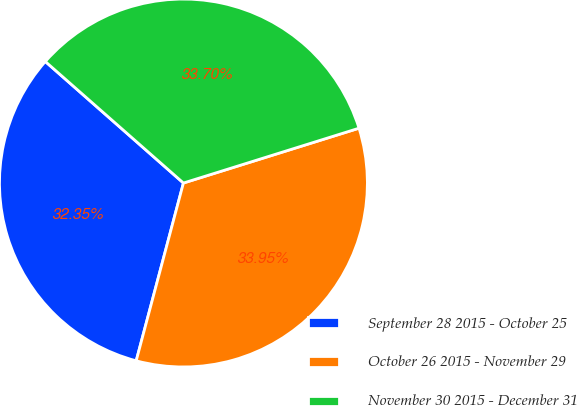Convert chart to OTSL. <chart><loc_0><loc_0><loc_500><loc_500><pie_chart><fcel>September 28 2015 - October 25<fcel>October 26 2015 - November 29<fcel>November 30 2015 - December 31<nl><fcel>32.35%<fcel>33.95%<fcel>33.7%<nl></chart> 